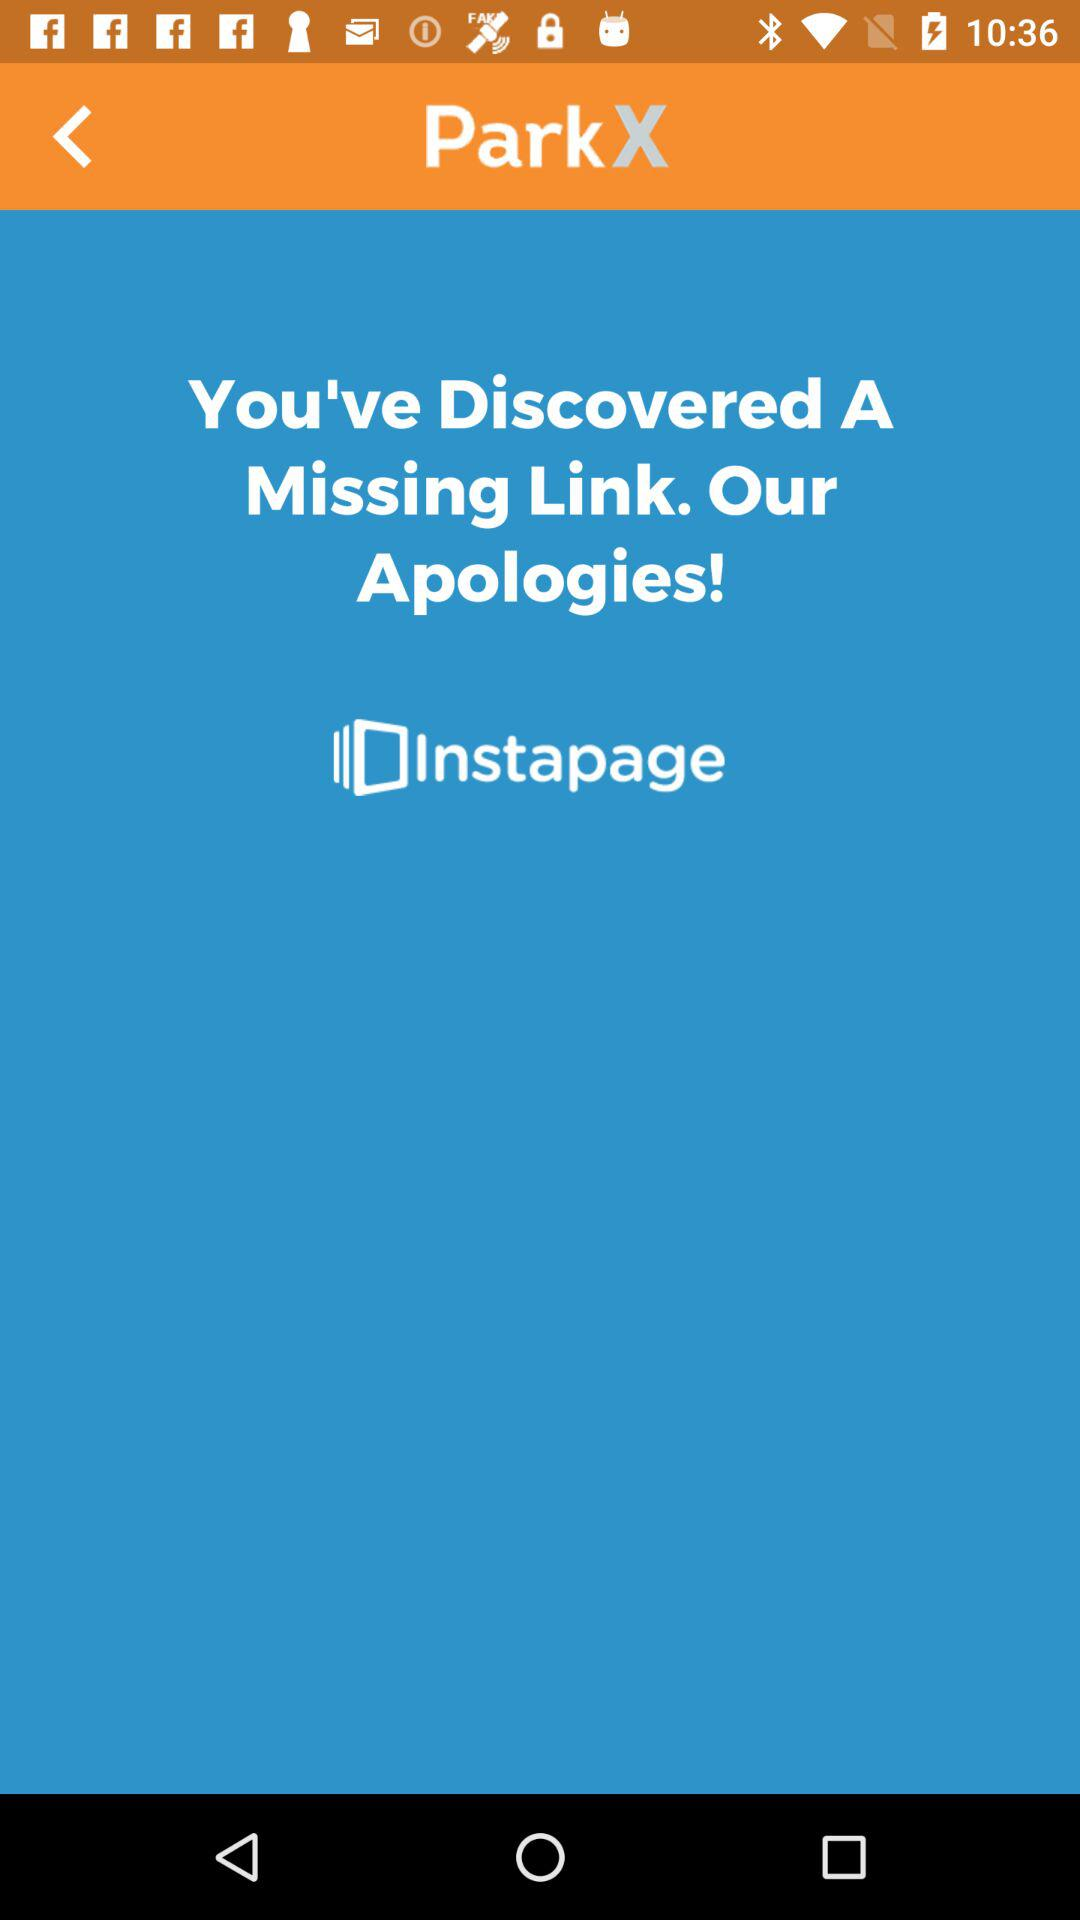What is the developer name? The developer name is "ParkX". 